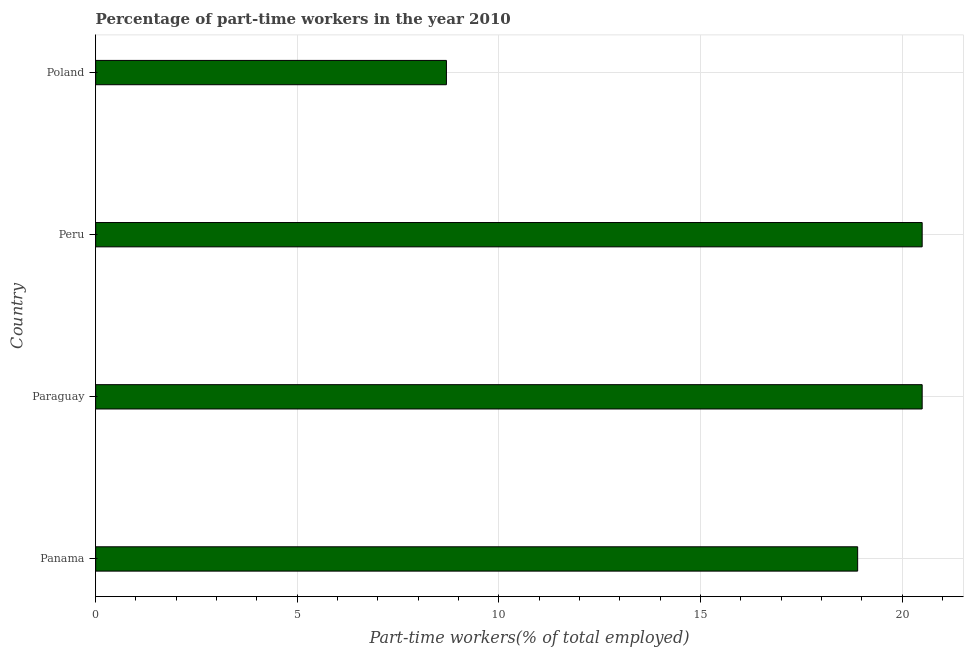Does the graph contain any zero values?
Your response must be concise. No. What is the title of the graph?
Offer a terse response. Percentage of part-time workers in the year 2010. What is the label or title of the X-axis?
Give a very brief answer. Part-time workers(% of total employed). What is the label or title of the Y-axis?
Your answer should be very brief. Country. What is the percentage of part-time workers in Poland?
Your response must be concise. 8.7. Across all countries, what is the maximum percentage of part-time workers?
Your answer should be very brief. 20.5. Across all countries, what is the minimum percentage of part-time workers?
Provide a succinct answer. 8.7. In which country was the percentage of part-time workers maximum?
Provide a short and direct response. Paraguay. What is the sum of the percentage of part-time workers?
Make the answer very short. 68.6. What is the average percentage of part-time workers per country?
Offer a very short reply. 17.15. What is the median percentage of part-time workers?
Keep it short and to the point. 19.7. What is the ratio of the percentage of part-time workers in Peru to that in Poland?
Offer a terse response. 2.36. What is the difference between the highest and the second highest percentage of part-time workers?
Give a very brief answer. 0. In how many countries, is the percentage of part-time workers greater than the average percentage of part-time workers taken over all countries?
Ensure brevity in your answer.  3. How many bars are there?
Provide a succinct answer. 4. What is the difference between two consecutive major ticks on the X-axis?
Give a very brief answer. 5. What is the Part-time workers(% of total employed) of Panama?
Provide a short and direct response. 18.9. What is the Part-time workers(% of total employed) in Peru?
Your answer should be very brief. 20.5. What is the Part-time workers(% of total employed) in Poland?
Keep it short and to the point. 8.7. What is the difference between the Part-time workers(% of total employed) in Panama and Paraguay?
Offer a very short reply. -1.6. What is the difference between the Part-time workers(% of total employed) in Panama and Peru?
Provide a succinct answer. -1.6. What is the difference between the Part-time workers(% of total employed) in Paraguay and Peru?
Your answer should be compact. 0. What is the ratio of the Part-time workers(% of total employed) in Panama to that in Paraguay?
Give a very brief answer. 0.92. What is the ratio of the Part-time workers(% of total employed) in Panama to that in Peru?
Provide a succinct answer. 0.92. What is the ratio of the Part-time workers(% of total employed) in Panama to that in Poland?
Your answer should be compact. 2.17. What is the ratio of the Part-time workers(% of total employed) in Paraguay to that in Poland?
Your answer should be very brief. 2.36. What is the ratio of the Part-time workers(% of total employed) in Peru to that in Poland?
Provide a short and direct response. 2.36. 